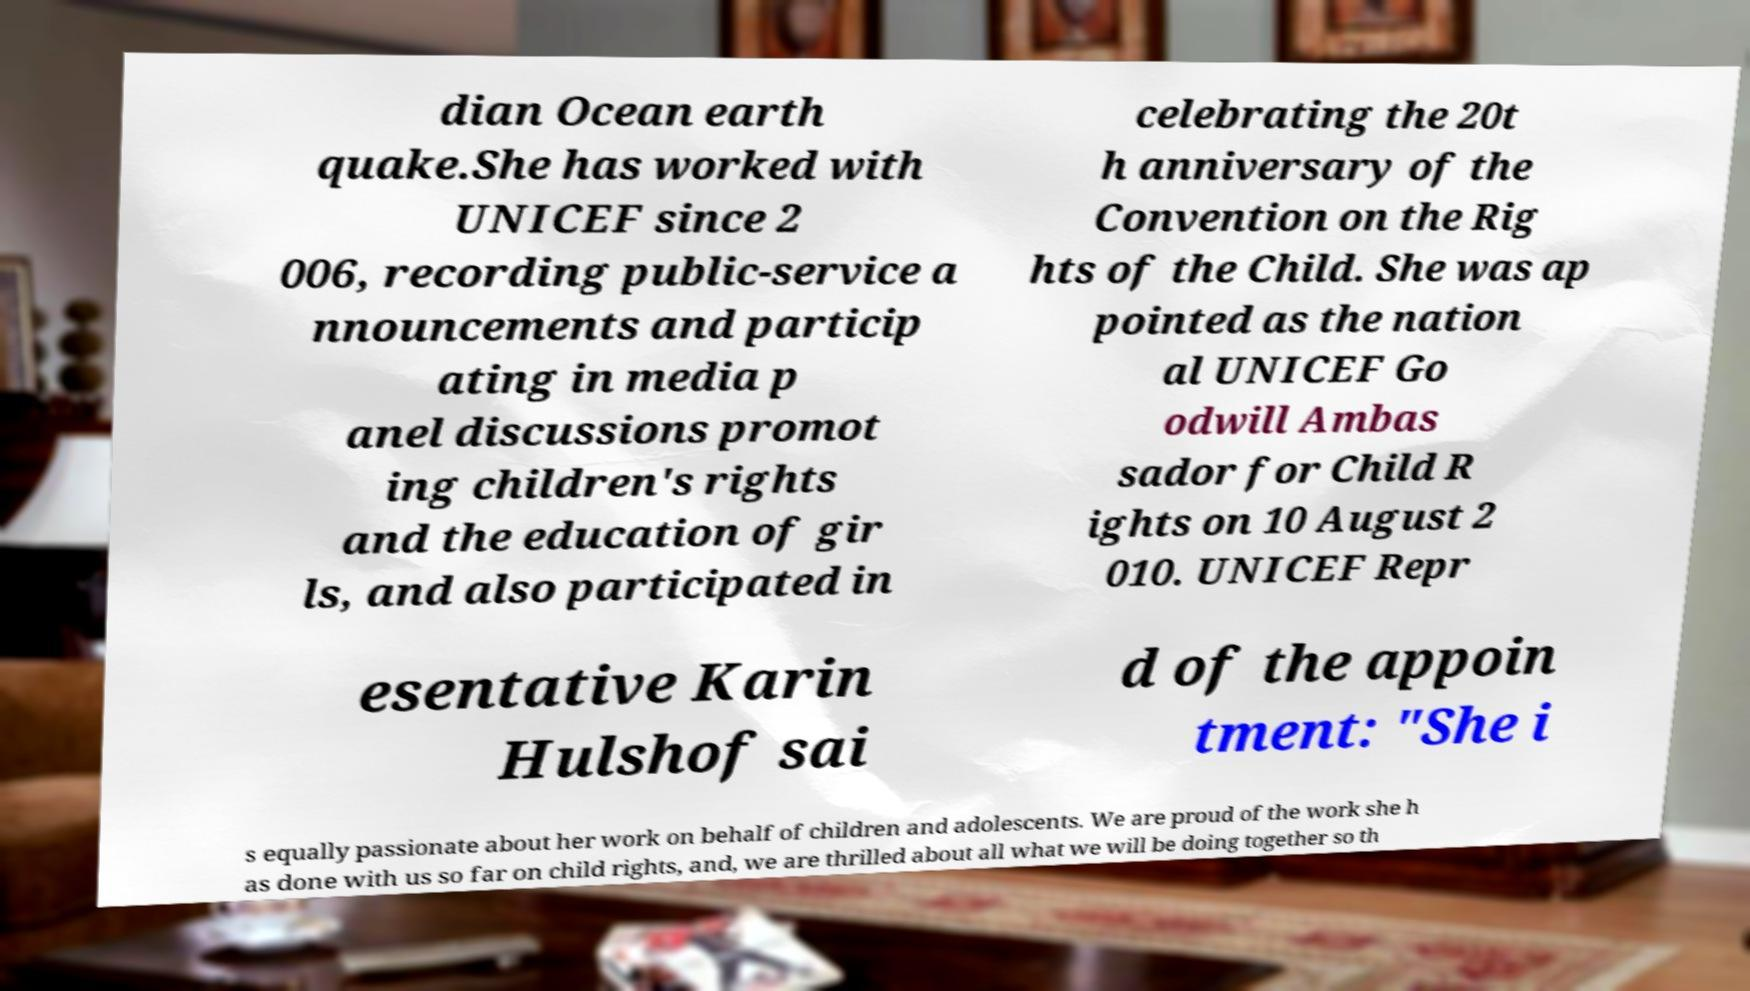There's text embedded in this image that I need extracted. Can you transcribe it verbatim? dian Ocean earth quake.She has worked with UNICEF since 2 006, recording public-service a nnouncements and particip ating in media p anel discussions promot ing children's rights and the education of gir ls, and also participated in celebrating the 20t h anniversary of the Convention on the Rig hts of the Child. She was ap pointed as the nation al UNICEF Go odwill Ambas sador for Child R ights on 10 August 2 010. UNICEF Repr esentative Karin Hulshof sai d of the appoin tment: "She i s equally passionate about her work on behalf of children and adolescents. We are proud of the work she h as done with us so far on child rights, and, we are thrilled about all what we will be doing together so th 